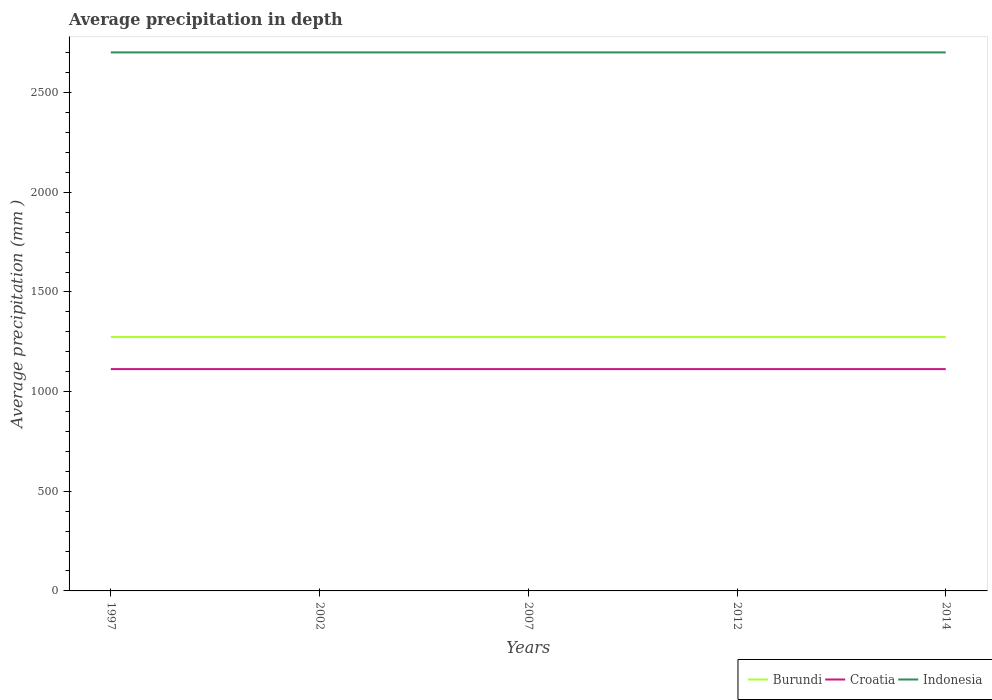Across all years, what is the maximum average precipitation in Croatia?
Provide a short and direct response. 1113. In which year was the average precipitation in Indonesia maximum?
Offer a terse response. 1997. What is the difference between the highest and the second highest average precipitation in Croatia?
Offer a very short reply. 0. Is the average precipitation in Indonesia strictly greater than the average precipitation in Burundi over the years?
Provide a short and direct response. No. How many lines are there?
Keep it short and to the point. 3. How many years are there in the graph?
Your response must be concise. 5. What is the difference between two consecutive major ticks on the Y-axis?
Provide a short and direct response. 500. Does the graph contain grids?
Your answer should be compact. No. Where does the legend appear in the graph?
Your answer should be very brief. Bottom right. How are the legend labels stacked?
Give a very brief answer. Horizontal. What is the title of the graph?
Keep it short and to the point. Average precipitation in depth. What is the label or title of the X-axis?
Provide a succinct answer. Years. What is the label or title of the Y-axis?
Provide a succinct answer. Average precipitation (mm ). What is the Average precipitation (mm ) in Burundi in 1997?
Offer a very short reply. 1274. What is the Average precipitation (mm ) of Croatia in 1997?
Ensure brevity in your answer.  1113. What is the Average precipitation (mm ) of Indonesia in 1997?
Provide a short and direct response. 2702. What is the Average precipitation (mm ) of Burundi in 2002?
Provide a short and direct response. 1274. What is the Average precipitation (mm ) in Croatia in 2002?
Offer a very short reply. 1113. What is the Average precipitation (mm ) in Indonesia in 2002?
Give a very brief answer. 2702. What is the Average precipitation (mm ) in Burundi in 2007?
Your answer should be very brief. 1274. What is the Average precipitation (mm ) of Croatia in 2007?
Make the answer very short. 1113. What is the Average precipitation (mm ) in Indonesia in 2007?
Give a very brief answer. 2702. What is the Average precipitation (mm ) of Burundi in 2012?
Your answer should be compact. 1274. What is the Average precipitation (mm ) of Croatia in 2012?
Offer a terse response. 1113. What is the Average precipitation (mm ) of Indonesia in 2012?
Your answer should be compact. 2702. What is the Average precipitation (mm ) in Burundi in 2014?
Your answer should be compact. 1274. What is the Average precipitation (mm ) in Croatia in 2014?
Keep it short and to the point. 1113. What is the Average precipitation (mm ) of Indonesia in 2014?
Provide a succinct answer. 2702. Across all years, what is the maximum Average precipitation (mm ) in Burundi?
Your answer should be very brief. 1274. Across all years, what is the maximum Average precipitation (mm ) of Croatia?
Your answer should be compact. 1113. Across all years, what is the maximum Average precipitation (mm ) of Indonesia?
Provide a short and direct response. 2702. Across all years, what is the minimum Average precipitation (mm ) in Burundi?
Your response must be concise. 1274. Across all years, what is the minimum Average precipitation (mm ) of Croatia?
Provide a succinct answer. 1113. Across all years, what is the minimum Average precipitation (mm ) of Indonesia?
Your answer should be very brief. 2702. What is the total Average precipitation (mm ) in Burundi in the graph?
Give a very brief answer. 6370. What is the total Average precipitation (mm ) in Croatia in the graph?
Your response must be concise. 5565. What is the total Average precipitation (mm ) of Indonesia in the graph?
Provide a succinct answer. 1.35e+04. What is the difference between the Average precipitation (mm ) of Burundi in 1997 and that in 2002?
Make the answer very short. 0. What is the difference between the Average precipitation (mm ) of Indonesia in 1997 and that in 2002?
Your answer should be very brief. 0. What is the difference between the Average precipitation (mm ) of Burundi in 1997 and that in 2007?
Make the answer very short. 0. What is the difference between the Average precipitation (mm ) of Indonesia in 1997 and that in 2007?
Give a very brief answer. 0. What is the difference between the Average precipitation (mm ) of Burundi in 1997 and that in 2012?
Ensure brevity in your answer.  0. What is the difference between the Average precipitation (mm ) of Burundi in 1997 and that in 2014?
Your answer should be compact. 0. What is the difference between the Average precipitation (mm ) in Croatia in 1997 and that in 2014?
Keep it short and to the point. 0. What is the difference between the Average precipitation (mm ) in Indonesia in 1997 and that in 2014?
Offer a terse response. 0. What is the difference between the Average precipitation (mm ) of Croatia in 2002 and that in 2007?
Ensure brevity in your answer.  0. What is the difference between the Average precipitation (mm ) in Indonesia in 2002 and that in 2007?
Offer a terse response. 0. What is the difference between the Average precipitation (mm ) in Croatia in 2002 and that in 2014?
Make the answer very short. 0. What is the difference between the Average precipitation (mm ) in Croatia in 2007 and that in 2012?
Provide a short and direct response. 0. What is the difference between the Average precipitation (mm ) of Indonesia in 2007 and that in 2012?
Ensure brevity in your answer.  0. What is the difference between the Average precipitation (mm ) in Indonesia in 2007 and that in 2014?
Give a very brief answer. 0. What is the difference between the Average precipitation (mm ) in Burundi in 2012 and that in 2014?
Ensure brevity in your answer.  0. What is the difference between the Average precipitation (mm ) of Croatia in 2012 and that in 2014?
Provide a succinct answer. 0. What is the difference between the Average precipitation (mm ) in Burundi in 1997 and the Average precipitation (mm ) in Croatia in 2002?
Offer a very short reply. 161. What is the difference between the Average precipitation (mm ) of Burundi in 1997 and the Average precipitation (mm ) of Indonesia in 2002?
Offer a terse response. -1428. What is the difference between the Average precipitation (mm ) in Croatia in 1997 and the Average precipitation (mm ) in Indonesia in 2002?
Make the answer very short. -1589. What is the difference between the Average precipitation (mm ) in Burundi in 1997 and the Average precipitation (mm ) in Croatia in 2007?
Offer a very short reply. 161. What is the difference between the Average precipitation (mm ) of Burundi in 1997 and the Average precipitation (mm ) of Indonesia in 2007?
Keep it short and to the point. -1428. What is the difference between the Average precipitation (mm ) of Croatia in 1997 and the Average precipitation (mm ) of Indonesia in 2007?
Your response must be concise. -1589. What is the difference between the Average precipitation (mm ) of Burundi in 1997 and the Average precipitation (mm ) of Croatia in 2012?
Provide a succinct answer. 161. What is the difference between the Average precipitation (mm ) in Burundi in 1997 and the Average precipitation (mm ) in Indonesia in 2012?
Ensure brevity in your answer.  -1428. What is the difference between the Average precipitation (mm ) in Croatia in 1997 and the Average precipitation (mm ) in Indonesia in 2012?
Offer a very short reply. -1589. What is the difference between the Average precipitation (mm ) of Burundi in 1997 and the Average precipitation (mm ) of Croatia in 2014?
Your answer should be compact. 161. What is the difference between the Average precipitation (mm ) in Burundi in 1997 and the Average precipitation (mm ) in Indonesia in 2014?
Make the answer very short. -1428. What is the difference between the Average precipitation (mm ) of Croatia in 1997 and the Average precipitation (mm ) of Indonesia in 2014?
Give a very brief answer. -1589. What is the difference between the Average precipitation (mm ) in Burundi in 2002 and the Average precipitation (mm ) in Croatia in 2007?
Offer a terse response. 161. What is the difference between the Average precipitation (mm ) of Burundi in 2002 and the Average precipitation (mm ) of Indonesia in 2007?
Your answer should be very brief. -1428. What is the difference between the Average precipitation (mm ) of Croatia in 2002 and the Average precipitation (mm ) of Indonesia in 2007?
Provide a succinct answer. -1589. What is the difference between the Average precipitation (mm ) in Burundi in 2002 and the Average precipitation (mm ) in Croatia in 2012?
Offer a very short reply. 161. What is the difference between the Average precipitation (mm ) of Burundi in 2002 and the Average precipitation (mm ) of Indonesia in 2012?
Your response must be concise. -1428. What is the difference between the Average precipitation (mm ) of Croatia in 2002 and the Average precipitation (mm ) of Indonesia in 2012?
Your answer should be very brief. -1589. What is the difference between the Average precipitation (mm ) in Burundi in 2002 and the Average precipitation (mm ) in Croatia in 2014?
Offer a terse response. 161. What is the difference between the Average precipitation (mm ) of Burundi in 2002 and the Average precipitation (mm ) of Indonesia in 2014?
Offer a very short reply. -1428. What is the difference between the Average precipitation (mm ) of Croatia in 2002 and the Average precipitation (mm ) of Indonesia in 2014?
Your response must be concise. -1589. What is the difference between the Average precipitation (mm ) in Burundi in 2007 and the Average precipitation (mm ) in Croatia in 2012?
Provide a succinct answer. 161. What is the difference between the Average precipitation (mm ) of Burundi in 2007 and the Average precipitation (mm ) of Indonesia in 2012?
Give a very brief answer. -1428. What is the difference between the Average precipitation (mm ) in Croatia in 2007 and the Average precipitation (mm ) in Indonesia in 2012?
Your answer should be compact. -1589. What is the difference between the Average precipitation (mm ) in Burundi in 2007 and the Average precipitation (mm ) in Croatia in 2014?
Your answer should be very brief. 161. What is the difference between the Average precipitation (mm ) of Burundi in 2007 and the Average precipitation (mm ) of Indonesia in 2014?
Provide a short and direct response. -1428. What is the difference between the Average precipitation (mm ) of Croatia in 2007 and the Average precipitation (mm ) of Indonesia in 2014?
Make the answer very short. -1589. What is the difference between the Average precipitation (mm ) of Burundi in 2012 and the Average precipitation (mm ) of Croatia in 2014?
Ensure brevity in your answer.  161. What is the difference between the Average precipitation (mm ) of Burundi in 2012 and the Average precipitation (mm ) of Indonesia in 2014?
Your answer should be compact. -1428. What is the difference between the Average precipitation (mm ) in Croatia in 2012 and the Average precipitation (mm ) in Indonesia in 2014?
Provide a succinct answer. -1589. What is the average Average precipitation (mm ) of Burundi per year?
Offer a very short reply. 1274. What is the average Average precipitation (mm ) in Croatia per year?
Offer a very short reply. 1113. What is the average Average precipitation (mm ) in Indonesia per year?
Keep it short and to the point. 2702. In the year 1997, what is the difference between the Average precipitation (mm ) of Burundi and Average precipitation (mm ) of Croatia?
Offer a terse response. 161. In the year 1997, what is the difference between the Average precipitation (mm ) in Burundi and Average precipitation (mm ) in Indonesia?
Your response must be concise. -1428. In the year 1997, what is the difference between the Average precipitation (mm ) of Croatia and Average precipitation (mm ) of Indonesia?
Give a very brief answer. -1589. In the year 2002, what is the difference between the Average precipitation (mm ) of Burundi and Average precipitation (mm ) of Croatia?
Provide a short and direct response. 161. In the year 2002, what is the difference between the Average precipitation (mm ) of Burundi and Average precipitation (mm ) of Indonesia?
Your response must be concise. -1428. In the year 2002, what is the difference between the Average precipitation (mm ) of Croatia and Average precipitation (mm ) of Indonesia?
Give a very brief answer. -1589. In the year 2007, what is the difference between the Average precipitation (mm ) in Burundi and Average precipitation (mm ) in Croatia?
Provide a short and direct response. 161. In the year 2007, what is the difference between the Average precipitation (mm ) in Burundi and Average precipitation (mm ) in Indonesia?
Provide a succinct answer. -1428. In the year 2007, what is the difference between the Average precipitation (mm ) of Croatia and Average precipitation (mm ) of Indonesia?
Make the answer very short. -1589. In the year 2012, what is the difference between the Average precipitation (mm ) in Burundi and Average precipitation (mm ) in Croatia?
Ensure brevity in your answer.  161. In the year 2012, what is the difference between the Average precipitation (mm ) of Burundi and Average precipitation (mm ) of Indonesia?
Make the answer very short. -1428. In the year 2012, what is the difference between the Average precipitation (mm ) in Croatia and Average precipitation (mm ) in Indonesia?
Provide a succinct answer. -1589. In the year 2014, what is the difference between the Average precipitation (mm ) of Burundi and Average precipitation (mm ) of Croatia?
Your answer should be very brief. 161. In the year 2014, what is the difference between the Average precipitation (mm ) in Burundi and Average precipitation (mm ) in Indonesia?
Provide a succinct answer. -1428. In the year 2014, what is the difference between the Average precipitation (mm ) in Croatia and Average precipitation (mm ) in Indonesia?
Provide a short and direct response. -1589. What is the ratio of the Average precipitation (mm ) in Burundi in 1997 to that in 2002?
Provide a short and direct response. 1. What is the ratio of the Average precipitation (mm ) of Croatia in 1997 to that in 2002?
Your answer should be compact. 1. What is the ratio of the Average precipitation (mm ) in Burundi in 1997 to that in 2007?
Offer a terse response. 1. What is the ratio of the Average precipitation (mm ) of Indonesia in 1997 to that in 2007?
Keep it short and to the point. 1. What is the ratio of the Average precipitation (mm ) in Croatia in 1997 to that in 2012?
Give a very brief answer. 1. What is the ratio of the Average precipitation (mm ) of Croatia in 2002 to that in 2012?
Offer a terse response. 1. What is the ratio of the Average precipitation (mm ) of Indonesia in 2002 to that in 2012?
Give a very brief answer. 1. What is the ratio of the Average precipitation (mm ) of Burundi in 2002 to that in 2014?
Your answer should be compact. 1. What is the ratio of the Average precipitation (mm ) of Indonesia in 2002 to that in 2014?
Give a very brief answer. 1. What is the ratio of the Average precipitation (mm ) in Burundi in 2007 to that in 2012?
Your answer should be compact. 1. What is the ratio of the Average precipitation (mm ) in Burundi in 2007 to that in 2014?
Ensure brevity in your answer.  1. What is the ratio of the Average precipitation (mm ) of Indonesia in 2007 to that in 2014?
Your response must be concise. 1. What is the ratio of the Average precipitation (mm ) in Burundi in 2012 to that in 2014?
Offer a terse response. 1. What is the ratio of the Average precipitation (mm ) in Indonesia in 2012 to that in 2014?
Your answer should be very brief. 1. What is the difference between the highest and the second highest Average precipitation (mm ) in Burundi?
Your response must be concise. 0. What is the difference between the highest and the lowest Average precipitation (mm ) in Burundi?
Your answer should be very brief. 0. What is the difference between the highest and the lowest Average precipitation (mm ) of Croatia?
Provide a succinct answer. 0. 